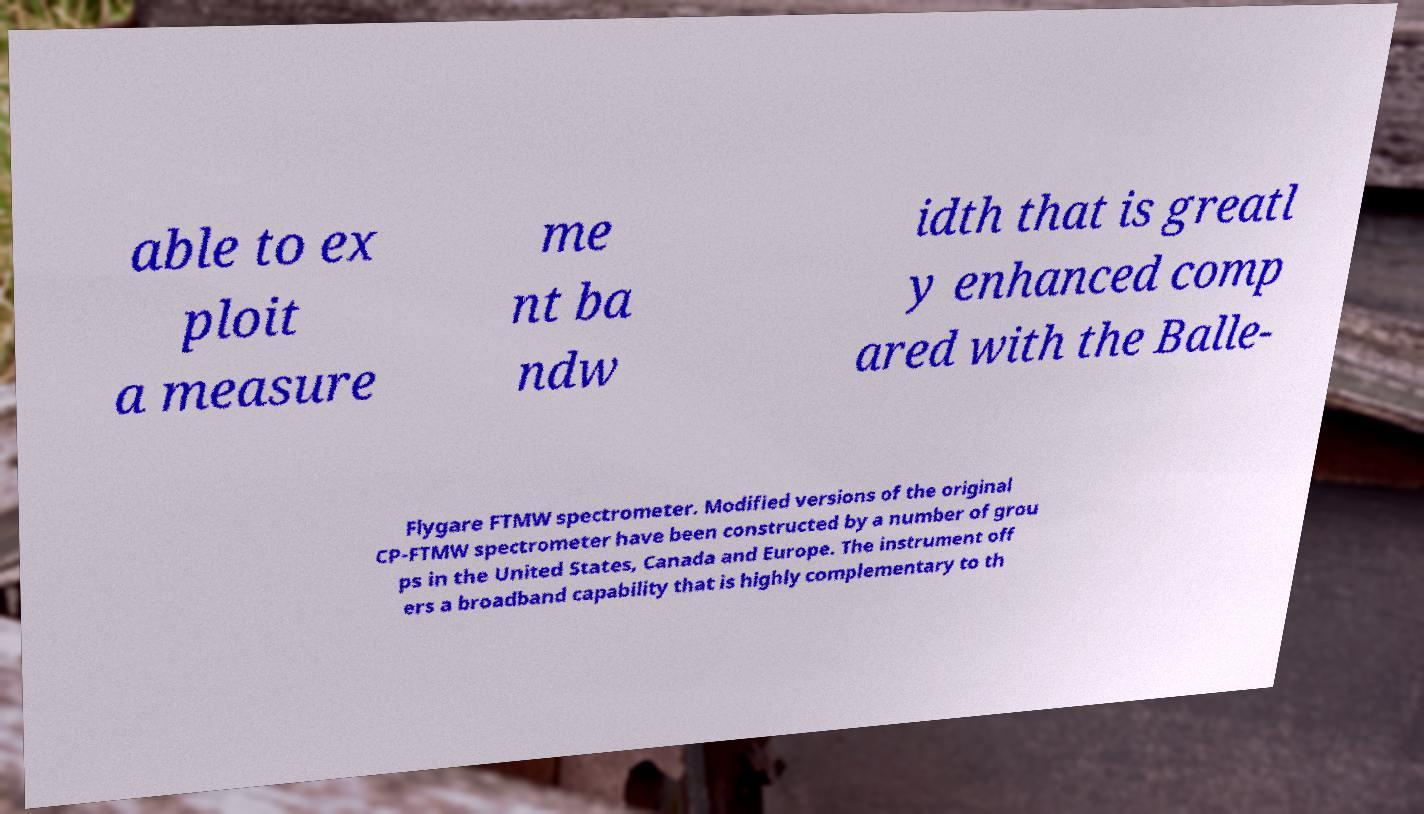For documentation purposes, I need the text within this image transcribed. Could you provide that? able to ex ploit a measure me nt ba ndw idth that is greatl y enhanced comp ared with the Balle- Flygare FTMW spectrometer. Modified versions of the original CP-FTMW spectrometer have been constructed by a number of grou ps in the United States, Canada and Europe. The instrument off ers a broadband capability that is highly complementary to th 